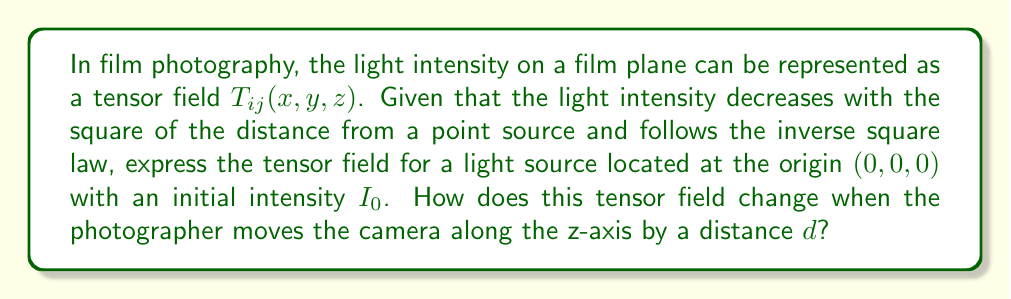Teach me how to tackle this problem. Let's approach this step-by-step:

1) First, we need to express the light intensity as a function of position. According to the inverse square law:

   $I(r) = \frac{I_0}{r^2}$

   where $r$ is the distance from the light source.

2) In Cartesian coordinates, $r^2 = x^2 + y^2 + z^2$. So, our intensity function becomes:

   $I(x, y, z) = \frac{I_0}{x^2 + y^2 + z^2}$

3) Now, we need to represent this as a tensor field. Since light intensity is a scalar quantity, we can represent it as a rank-2 tensor (matrix) where the diagonal elements are equal to the intensity:

   $$T_{ij}(x, y, z) = \frac{I_0}{x^2 + y^2 + z^2} \delta_{ij}$$

   where $\delta_{ij}$ is the Kronecker delta.

4) When the photographer moves the camera along the z-axis by a distance $d$, we need to shift our coordinate system. This is equivalent to replacing $z$ with $(z-d)$ in our tensor field:

   $$T_{ij}(x, y, z, d) = \frac{I_0}{x^2 + y^2 + (z-d)^2} \delta_{ij}$$

5) This new tensor field represents the light intensity distribution after moving the camera.
Answer: $$T_{ij}(x, y, z, d) = \frac{I_0}{x^2 + y^2 + (z-d)^2} \delta_{ij}$$ 